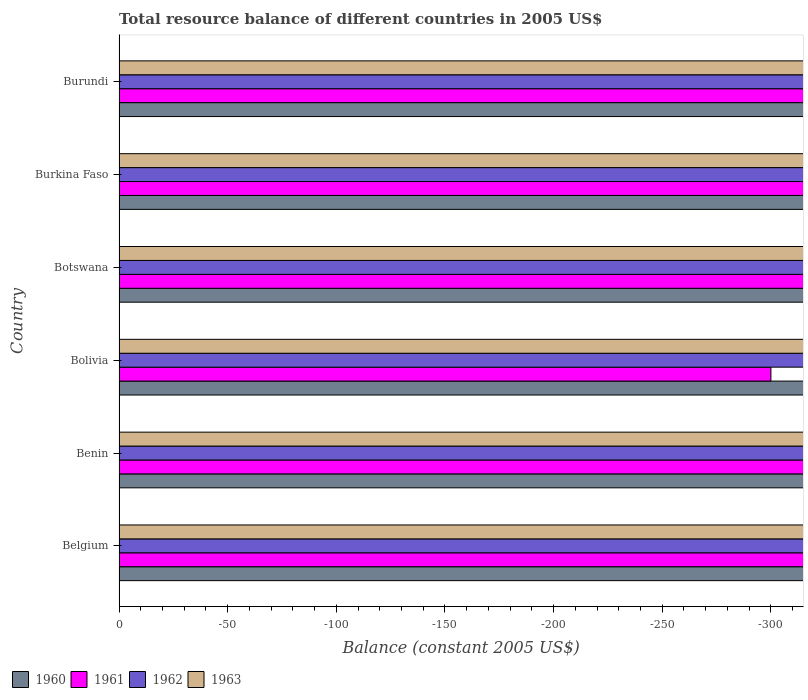Are the number of bars per tick equal to the number of legend labels?
Offer a terse response. No. Are the number of bars on each tick of the Y-axis equal?
Make the answer very short. Yes. How many bars are there on the 4th tick from the top?
Your response must be concise. 0. How many bars are there on the 2nd tick from the bottom?
Make the answer very short. 0. What is the label of the 5th group of bars from the top?
Provide a succinct answer. Benin. In how many cases, is the number of bars for a given country not equal to the number of legend labels?
Make the answer very short. 6. Across all countries, what is the minimum total resource balance in 1962?
Make the answer very short. 0. What is the difference between the total resource balance in 1963 in Burundi and the total resource balance in 1962 in Benin?
Ensure brevity in your answer.  0. Is it the case that in every country, the sum of the total resource balance in 1961 and total resource balance in 1962 is greater than the sum of total resource balance in 1960 and total resource balance in 1963?
Ensure brevity in your answer.  No. Is it the case that in every country, the sum of the total resource balance in 1961 and total resource balance in 1960 is greater than the total resource balance in 1963?
Provide a succinct answer. No. How many bars are there?
Your answer should be very brief. 0. What is the difference between two consecutive major ticks on the X-axis?
Provide a short and direct response. 50. Does the graph contain grids?
Offer a very short reply. No. How many legend labels are there?
Give a very brief answer. 4. What is the title of the graph?
Keep it short and to the point. Total resource balance of different countries in 2005 US$. What is the label or title of the X-axis?
Your answer should be very brief. Balance (constant 2005 US$). What is the Balance (constant 2005 US$) in 1962 in Belgium?
Offer a terse response. 0. What is the Balance (constant 2005 US$) of 1963 in Belgium?
Make the answer very short. 0. What is the Balance (constant 2005 US$) of 1960 in Benin?
Provide a succinct answer. 0. What is the Balance (constant 2005 US$) of 1961 in Benin?
Offer a terse response. 0. What is the Balance (constant 2005 US$) in 1963 in Benin?
Your answer should be very brief. 0. What is the Balance (constant 2005 US$) of 1960 in Bolivia?
Keep it short and to the point. 0. What is the Balance (constant 2005 US$) in 1961 in Bolivia?
Your answer should be very brief. 0. What is the Balance (constant 2005 US$) of 1960 in Botswana?
Keep it short and to the point. 0. What is the Balance (constant 2005 US$) in 1961 in Botswana?
Your answer should be compact. 0. What is the Balance (constant 2005 US$) in 1961 in Burkina Faso?
Offer a very short reply. 0. What is the Balance (constant 2005 US$) in 1962 in Burkina Faso?
Provide a succinct answer. 0. What is the Balance (constant 2005 US$) of 1963 in Burkina Faso?
Keep it short and to the point. 0. What is the Balance (constant 2005 US$) of 1960 in Burundi?
Your response must be concise. 0. What is the Balance (constant 2005 US$) of 1963 in Burundi?
Your answer should be compact. 0. What is the total Balance (constant 2005 US$) of 1962 in the graph?
Your answer should be very brief. 0. What is the total Balance (constant 2005 US$) of 1963 in the graph?
Provide a short and direct response. 0. What is the average Balance (constant 2005 US$) of 1962 per country?
Keep it short and to the point. 0. What is the average Balance (constant 2005 US$) in 1963 per country?
Your response must be concise. 0. 